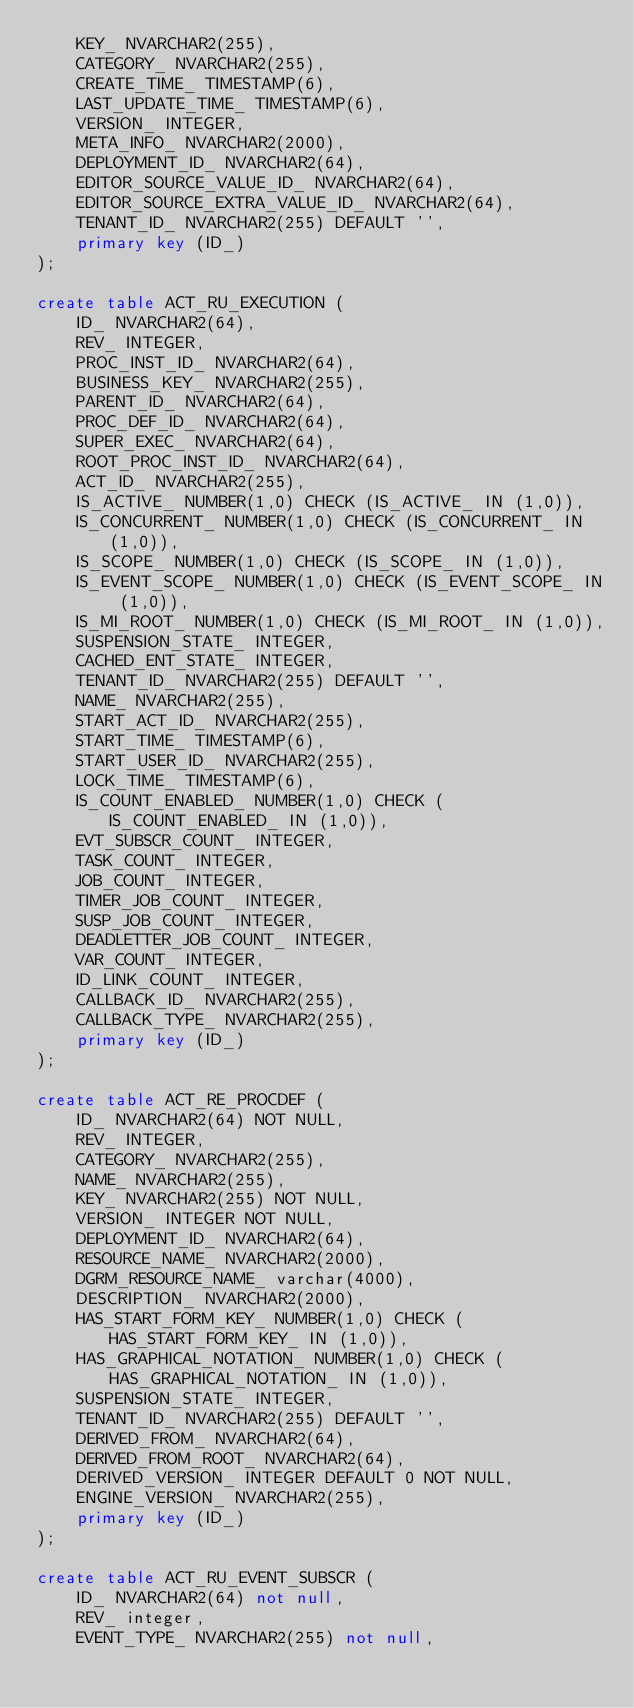<code> <loc_0><loc_0><loc_500><loc_500><_SQL_>    KEY_ NVARCHAR2(255),
    CATEGORY_ NVARCHAR2(255),
    CREATE_TIME_ TIMESTAMP(6),
    LAST_UPDATE_TIME_ TIMESTAMP(6),
    VERSION_ INTEGER,
    META_INFO_ NVARCHAR2(2000),
    DEPLOYMENT_ID_ NVARCHAR2(64),
    EDITOR_SOURCE_VALUE_ID_ NVARCHAR2(64),
    EDITOR_SOURCE_EXTRA_VALUE_ID_ NVARCHAR2(64),
    TENANT_ID_ NVARCHAR2(255) DEFAULT '',
    primary key (ID_)
);

create table ACT_RU_EXECUTION (
    ID_ NVARCHAR2(64),
    REV_ INTEGER,
    PROC_INST_ID_ NVARCHAR2(64),
    BUSINESS_KEY_ NVARCHAR2(255),
    PARENT_ID_ NVARCHAR2(64),
    PROC_DEF_ID_ NVARCHAR2(64),
    SUPER_EXEC_ NVARCHAR2(64),
    ROOT_PROC_INST_ID_ NVARCHAR2(64),
    ACT_ID_ NVARCHAR2(255),
    IS_ACTIVE_ NUMBER(1,0) CHECK (IS_ACTIVE_ IN (1,0)),
    IS_CONCURRENT_ NUMBER(1,0) CHECK (IS_CONCURRENT_ IN (1,0)),
    IS_SCOPE_ NUMBER(1,0) CHECK (IS_SCOPE_ IN (1,0)),
    IS_EVENT_SCOPE_ NUMBER(1,0) CHECK (IS_EVENT_SCOPE_ IN (1,0)),
    IS_MI_ROOT_ NUMBER(1,0) CHECK (IS_MI_ROOT_ IN (1,0)),
    SUSPENSION_STATE_ INTEGER,
    CACHED_ENT_STATE_ INTEGER,
    TENANT_ID_ NVARCHAR2(255) DEFAULT '',
    NAME_ NVARCHAR2(255),
    START_ACT_ID_ NVARCHAR2(255),
    START_TIME_ TIMESTAMP(6),
    START_USER_ID_ NVARCHAR2(255),
    LOCK_TIME_ TIMESTAMP(6),
    IS_COUNT_ENABLED_ NUMBER(1,0) CHECK (IS_COUNT_ENABLED_ IN (1,0)),
    EVT_SUBSCR_COUNT_ INTEGER, 
    TASK_COUNT_ INTEGER, 
    JOB_COUNT_ INTEGER, 
    TIMER_JOB_COUNT_ INTEGER,
    SUSP_JOB_COUNT_ INTEGER,
    DEADLETTER_JOB_COUNT_ INTEGER,
    VAR_COUNT_ INTEGER, 
    ID_LINK_COUNT_ INTEGER,
    CALLBACK_ID_ NVARCHAR2(255),
    CALLBACK_TYPE_ NVARCHAR2(255),
    primary key (ID_)
);

create table ACT_RE_PROCDEF (
    ID_ NVARCHAR2(64) NOT NULL,
    REV_ INTEGER,
    CATEGORY_ NVARCHAR2(255),
    NAME_ NVARCHAR2(255),
    KEY_ NVARCHAR2(255) NOT NULL,
    VERSION_ INTEGER NOT NULL,
    DEPLOYMENT_ID_ NVARCHAR2(64),
    RESOURCE_NAME_ NVARCHAR2(2000),
    DGRM_RESOURCE_NAME_ varchar(4000),
    DESCRIPTION_ NVARCHAR2(2000),
    HAS_START_FORM_KEY_ NUMBER(1,0) CHECK (HAS_START_FORM_KEY_ IN (1,0)),
    HAS_GRAPHICAL_NOTATION_ NUMBER(1,0) CHECK (HAS_GRAPHICAL_NOTATION_ IN (1,0)),
    SUSPENSION_STATE_ INTEGER,
    TENANT_ID_ NVARCHAR2(255) DEFAULT '',
    DERIVED_FROM_ NVARCHAR2(64),
    DERIVED_FROM_ROOT_ NVARCHAR2(64),
    DERIVED_VERSION_ INTEGER DEFAULT 0 NOT NULL,
    ENGINE_VERSION_ NVARCHAR2(255),
    primary key (ID_)
);

create table ACT_RU_EVENT_SUBSCR (
    ID_ NVARCHAR2(64) not null,
    REV_ integer,
    EVENT_TYPE_ NVARCHAR2(255) not null,</code> 